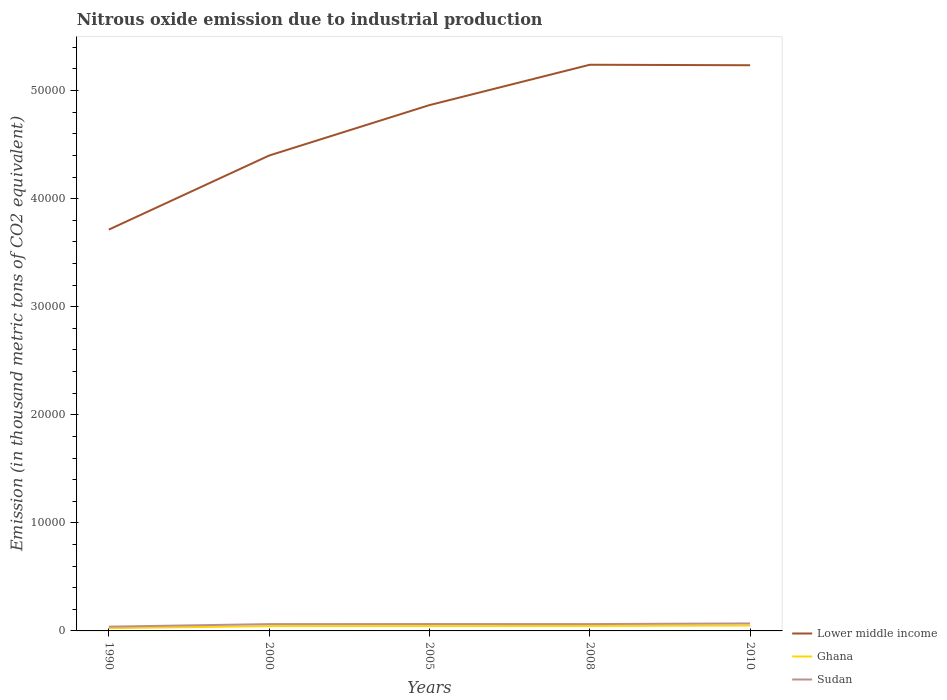Does the line corresponding to Ghana intersect with the line corresponding to Sudan?
Offer a terse response. No. Across all years, what is the maximum amount of nitrous oxide emitted in Sudan?
Offer a terse response. 395. What is the total amount of nitrous oxide emitted in Lower middle income in the graph?
Your answer should be very brief. -8354.9. What is the difference between the highest and the second highest amount of nitrous oxide emitted in Ghana?
Ensure brevity in your answer.  243.4. Is the amount of nitrous oxide emitted in Lower middle income strictly greater than the amount of nitrous oxide emitted in Sudan over the years?
Your answer should be very brief. No. How many years are there in the graph?
Make the answer very short. 5. What is the difference between two consecutive major ticks on the Y-axis?
Make the answer very short. 10000. Are the values on the major ticks of Y-axis written in scientific E-notation?
Your answer should be compact. No. Does the graph contain any zero values?
Keep it short and to the point. No. How are the legend labels stacked?
Offer a very short reply. Vertical. What is the title of the graph?
Provide a short and direct response. Nitrous oxide emission due to industrial production. Does "Myanmar" appear as one of the legend labels in the graph?
Make the answer very short. No. What is the label or title of the X-axis?
Keep it short and to the point. Years. What is the label or title of the Y-axis?
Offer a terse response. Emission (in thousand metric tons of CO2 equivalent). What is the Emission (in thousand metric tons of CO2 equivalent) in Lower middle income in 1990?
Ensure brevity in your answer.  3.71e+04. What is the Emission (in thousand metric tons of CO2 equivalent) in Ghana in 1990?
Provide a short and direct response. 256. What is the Emission (in thousand metric tons of CO2 equivalent) of Sudan in 1990?
Provide a short and direct response. 395. What is the Emission (in thousand metric tons of CO2 equivalent) in Lower middle income in 2000?
Keep it short and to the point. 4.40e+04. What is the Emission (in thousand metric tons of CO2 equivalent) in Ghana in 2000?
Give a very brief answer. 443.1. What is the Emission (in thousand metric tons of CO2 equivalent) of Sudan in 2000?
Your answer should be very brief. 630.1. What is the Emission (in thousand metric tons of CO2 equivalent) of Lower middle income in 2005?
Give a very brief answer. 4.87e+04. What is the Emission (in thousand metric tons of CO2 equivalent) of Ghana in 2005?
Your answer should be compact. 449.9. What is the Emission (in thousand metric tons of CO2 equivalent) of Sudan in 2005?
Your response must be concise. 637.4. What is the Emission (in thousand metric tons of CO2 equivalent) of Lower middle income in 2008?
Offer a terse response. 5.24e+04. What is the Emission (in thousand metric tons of CO2 equivalent) in Ghana in 2008?
Your response must be concise. 458.8. What is the Emission (in thousand metric tons of CO2 equivalent) of Sudan in 2008?
Offer a very short reply. 632.8. What is the Emission (in thousand metric tons of CO2 equivalent) in Lower middle income in 2010?
Ensure brevity in your answer.  5.23e+04. What is the Emission (in thousand metric tons of CO2 equivalent) of Ghana in 2010?
Ensure brevity in your answer.  499.4. What is the Emission (in thousand metric tons of CO2 equivalent) of Sudan in 2010?
Offer a terse response. 694.6. Across all years, what is the maximum Emission (in thousand metric tons of CO2 equivalent) in Lower middle income?
Ensure brevity in your answer.  5.24e+04. Across all years, what is the maximum Emission (in thousand metric tons of CO2 equivalent) of Ghana?
Make the answer very short. 499.4. Across all years, what is the maximum Emission (in thousand metric tons of CO2 equivalent) in Sudan?
Make the answer very short. 694.6. Across all years, what is the minimum Emission (in thousand metric tons of CO2 equivalent) of Lower middle income?
Your answer should be compact. 3.71e+04. Across all years, what is the minimum Emission (in thousand metric tons of CO2 equivalent) of Ghana?
Your response must be concise. 256. Across all years, what is the minimum Emission (in thousand metric tons of CO2 equivalent) of Sudan?
Your answer should be very brief. 395. What is the total Emission (in thousand metric tons of CO2 equivalent) in Lower middle income in the graph?
Offer a very short reply. 2.35e+05. What is the total Emission (in thousand metric tons of CO2 equivalent) in Ghana in the graph?
Offer a very short reply. 2107.2. What is the total Emission (in thousand metric tons of CO2 equivalent) in Sudan in the graph?
Your answer should be very brief. 2989.9. What is the difference between the Emission (in thousand metric tons of CO2 equivalent) in Lower middle income in 1990 and that in 2000?
Provide a succinct answer. -6854.5. What is the difference between the Emission (in thousand metric tons of CO2 equivalent) of Ghana in 1990 and that in 2000?
Offer a terse response. -187.1. What is the difference between the Emission (in thousand metric tons of CO2 equivalent) of Sudan in 1990 and that in 2000?
Your response must be concise. -235.1. What is the difference between the Emission (in thousand metric tons of CO2 equivalent) in Lower middle income in 1990 and that in 2005?
Your response must be concise. -1.15e+04. What is the difference between the Emission (in thousand metric tons of CO2 equivalent) of Ghana in 1990 and that in 2005?
Keep it short and to the point. -193.9. What is the difference between the Emission (in thousand metric tons of CO2 equivalent) of Sudan in 1990 and that in 2005?
Your response must be concise. -242.4. What is the difference between the Emission (in thousand metric tons of CO2 equivalent) of Lower middle income in 1990 and that in 2008?
Your answer should be compact. -1.53e+04. What is the difference between the Emission (in thousand metric tons of CO2 equivalent) in Ghana in 1990 and that in 2008?
Keep it short and to the point. -202.8. What is the difference between the Emission (in thousand metric tons of CO2 equivalent) of Sudan in 1990 and that in 2008?
Provide a short and direct response. -237.8. What is the difference between the Emission (in thousand metric tons of CO2 equivalent) in Lower middle income in 1990 and that in 2010?
Ensure brevity in your answer.  -1.52e+04. What is the difference between the Emission (in thousand metric tons of CO2 equivalent) of Ghana in 1990 and that in 2010?
Give a very brief answer. -243.4. What is the difference between the Emission (in thousand metric tons of CO2 equivalent) of Sudan in 1990 and that in 2010?
Ensure brevity in your answer.  -299.6. What is the difference between the Emission (in thousand metric tons of CO2 equivalent) in Lower middle income in 2000 and that in 2005?
Make the answer very short. -4665.5. What is the difference between the Emission (in thousand metric tons of CO2 equivalent) of Ghana in 2000 and that in 2005?
Ensure brevity in your answer.  -6.8. What is the difference between the Emission (in thousand metric tons of CO2 equivalent) of Sudan in 2000 and that in 2005?
Ensure brevity in your answer.  -7.3. What is the difference between the Emission (in thousand metric tons of CO2 equivalent) in Lower middle income in 2000 and that in 2008?
Your response must be concise. -8400.2. What is the difference between the Emission (in thousand metric tons of CO2 equivalent) of Ghana in 2000 and that in 2008?
Make the answer very short. -15.7. What is the difference between the Emission (in thousand metric tons of CO2 equivalent) of Sudan in 2000 and that in 2008?
Ensure brevity in your answer.  -2.7. What is the difference between the Emission (in thousand metric tons of CO2 equivalent) in Lower middle income in 2000 and that in 2010?
Offer a terse response. -8354.9. What is the difference between the Emission (in thousand metric tons of CO2 equivalent) in Ghana in 2000 and that in 2010?
Provide a short and direct response. -56.3. What is the difference between the Emission (in thousand metric tons of CO2 equivalent) in Sudan in 2000 and that in 2010?
Offer a terse response. -64.5. What is the difference between the Emission (in thousand metric tons of CO2 equivalent) in Lower middle income in 2005 and that in 2008?
Give a very brief answer. -3734.7. What is the difference between the Emission (in thousand metric tons of CO2 equivalent) in Ghana in 2005 and that in 2008?
Provide a short and direct response. -8.9. What is the difference between the Emission (in thousand metric tons of CO2 equivalent) of Sudan in 2005 and that in 2008?
Your response must be concise. 4.6. What is the difference between the Emission (in thousand metric tons of CO2 equivalent) of Lower middle income in 2005 and that in 2010?
Provide a short and direct response. -3689.4. What is the difference between the Emission (in thousand metric tons of CO2 equivalent) of Ghana in 2005 and that in 2010?
Offer a very short reply. -49.5. What is the difference between the Emission (in thousand metric tons of CO2 equivalent) in Sudan in 2005 and that in 2010?
Make the answer very short. -57.2. What is the difference between the Emission (in thousand metric tons of CO2 equivalent) in Lower middle income in 2008 and that in 2010?
Offer a very short reply. 45.3. What is the difference between the Emission (in thousand metric tons of CO2 equivalent) of Ghana in 2008 and that in 2010?
Keep it short and to the point. -40.6. What is the difference between the Emission (in thousand metric tons of CO2 equivalent) of Sudan in 2008 and that in 2010?
Give a very brief answer. -61.8. What is the difference between the Emission (in thousand metric tons of CO2 equivalent) of Lower middle income in 1990 and the Emission (in thousand metric tons of CO2 equivalent) of Ghana in 2000?
Your answer should be very brief. 3.67e+04. What is the difference between the Emission (in thousand metric tons of CO2 equivalent) in Lower middle income in 1990 and the Emission (in thousand metric tons of CO2 equivalent) in Sudan in 2000?
Offer a terse response. 3.65e+04. What is the difference between the Emission (in thousand metric tons of CO2 equivalent) in Ghana in 1990 and the Emission (in thousand metric tons of CO2 equivalent) in Sudan in 2000?
Your answer should be very brief. -374.1. What is the difference between the Emission (in thousand metric tons of CO2 equivalent) of Lower middle income in 1990 and the Emission (in thousand metric tons of CO2 equivalent) of Ghana in 2005?
Your answer should be very brief. 3.67e+04. What is the difference between the Emission (in thousand metric tons of CO2 equivalent) of Lower middle income in 1990 and the Emission (in thousand metric tons of CO2 equivalent) of Sudan in 2005?
Your answer should be very brief. 3.65e+04. What is the difference between the Emission (in thousand metric tons of CO2 equivalent) in Ghana in 1990 and the Emission (in thousand metric tons of CO2 equivalent) in Sudan in 2005?
Offer a terse response. -381.4. What is the difference between the Emission (in thousand metric tons of CO2 equivalent) of Lower middle income in 1990 and the Emission (in thousand metric tons of CO2 equivalent) of Ghana in 2008?
Your answer should be compact. 3.67e+04. What is the difference between the Emission (in thousand metric tons of CO2 equivalent) in Lower middle income in 1990 and the Emission (in thousand metric tons of CO2 equivalent) in Sudan in 2008?
Offer a very short reply. 3.65e+04. What is the difference between the Emission (in thousand metric tons of CO2 equivalent) of Ghana in 1990 and the Emission (in thousand metric tons of CO2 equivalent) of Sudan in 2008?
Your answer should be compact. -376.8. What is the difference between the Emission (in thousand metric tons of CO2 equivalent) of Lower middle income in 1990 and the Emission (in thousand metric tons of CO2 equivalent) of Ghana in 2010?
Provide a succinct answer. 3.66e+04. What is the difference between the Emission (in thousand metric tons of CO2 equivalent) of Lower middle income in 1990 and the Emission (in thousand metric tons of CO2 equivalent) of Sudan in 2010?
Offer a terse response. 3.64e+04. What is the difference between the Emission (in thousand metric tons of CO2 equivalent) of Ghana in 1990 and the Emission (in thousand metric tons of CO2 equivalent) of Sudan in 2010?
Your answer should be compact. -438.6. What is the difference between the Emission (in thousand metric tons of CO2 equivalent) in Lower middle income in 2000 and the Emission (in thousand metric tons of CO2 equivalent) in Ghana in 2005?
Your answer should be compact. 4.35e+04. What is the difference between the Emission (in thousand metric tons of CO2 equivalent) in Lower middle income in 2000 and the Emission (in thousand metric tons of CO2 equivalent) in Sudan in 2005?
Provide a succinct answer. 4.33e+04. What is the difference between the Emission (in thousand metric tons of CO2 equivalent) of Ghana in 2000 and the Emission (in thousand metric tons of CO2 equivalent) of Sudan in 2005?
Ensure brevity in your answer.  -194.3. What is the difference between the Emission (in thousand metric tons of CO2 equivalent) of Lower middle income in 2000 and the Emission (in thousand metric tons of CO2 equivalent) of Ghana in 2008?
Ensure brevity in your answer.  4.35e+04. What is the difference between the Emission (in thousand metric tons of CO2 equivalent) in Lower middle income in 2000 and the Emission (in thousand metric tons of CO2 equivalent) in Sudan in 2008?
Give a very brief answer. 4.34e+04. What is the difference between the Emission (in thousand metric tons of CO2 equivalent) of Ghana in 2000 and the Emission (in thousand metric tons of CO2 equivalent) of Sudan in 2008?
Your answer should be compact. -189.7. What is the difference between the Emission (in thousand metric tons of CO2 equivalent) in Lower middle income in 2000 and the Emission (in thousand metric tons of CO2 equivalent) in Ghana in 2010?
Ensure brevity in your answer.  4.35e+04. What is the difference between the Emission (in thousand metric tons of CO2 equivalent) in Lower middle income in 2000 and the Emission (in thousand metric tons of CO2 equivalent) in Sudan in 2010?
Your answer should be very brief. 4.33e+04. What is the difference between the Emission (in thousand metric tons of CO2 equivalent) in Ghana in 2000 and the Emission (in thousand metric tons of CO2 equivalent) in Sudan in 2010?
Offer a very short reply. -251.5. What is the difference between the Emission (in thousand metric tons of CO2 equivalent) of Lower middle income in 2005 and the Emission (in thousand metric tons of CO2 equivalent) of Ghana in 2008?
Your answer should be very brief. 4.82e+04. What is the difference between the Emission (in thousand metric tons of CO2 equivalent) of Lower middle income in 2005 and the Emission (in thousand metric tons of CO2 equivalent) of Sudan in 2008?
Make the answer very short. 4.80e+04. What is the difference between the Emission (in thousand metric tons of CO2 equivalent) in Ghana in 2005 and the Emission (in thousand metric tons of CO2 equivalent) in Sudan in 2008?
Ensure brevity in your answer.  -182.9. What is the difference between the Emission (in thousand metric tons of CO2 equivalent) in Lower middle income in 2005 and the Emission (in thousand metric tons of CO2 equivalent) in Ghana in 2010?
Offer a very short reply. 4.82e+04. What is the difference between the Emission (in thousand metric tons of CO2 equivalent) of Lower middle income in 2005 and the Emission (in thousand metric tons of CO2 equivalent) of Sudan in 2010?
Your answer should be compact. 4.80e+04. What is the difference between the Emission (in thousand metric tons of CO2 equivalent) in Ghana in 2005 and the Emission (in thousand metric tons of CO2 equivalent) in Sudan in 2010?
Your response must be concise. -244.7. What is the difference between the Emission (in thousand metric tons of CO2 equivalent) of Lower middle income in 2008 and the Emission (in thousand metric tons of CO2 equivalent) of Ghana in 2010?
Give a very brief answer. 5.19e+04. What is the difference between the Emission (in thousand metric tons of CO2 equivalent) of Lower middle income in 2008 and the Emission (in thousand metric tons of CO2 equivalent) of Sudan in 2010?
Provide a succinct answer. 5.17e+04. What is the difference between the Emission (in thousand metric tons of CO2 equivalent) in Ghana in 2008 and the Emission (in thousand metric tons of CO2 equivalent) in Sudan in 2010?
Provide a short and direct response. -235.8. What is the average Emission (in thousand metric tons of CO2 equivalent) of Lower middle income per year?
Make the answer very short. 4.69e+04. What is the average Emission (in thousand metric tons of CO2 equivalent) of Ghana per year?
Keep it short and to the point. 421.44. What is the average Emission (in thousand metric tons of CO2 equivalent) of Sudan per year?
Offer a terse response. 597.98. In the year 1990, what is the difference between the Emission (in thousand metric tons of CO2 equivalent) in Lower middle income and Emission (in thousand metric tons of CO2 equivalent) in Ghana?
Your answer should be very brief. 3.69e+04. In the year 1990, what is the difference between the Emission (in thousand metric tons of CO2 equivalent) in Lower middle income and Emission (in thousand metric tons of CO2 equivalent) in Sudan?
Your answer should be very brief. 3.67e+04. In the year 1990, what is the difference between the Emission (in thousand metric tons of CO2 equivalent) of Ghana and Emission (in thousand metric tons of CO2 equivalent) of Sudan?
Give a very brief answer. -139. In the year 2000, what is the difference between the Emission (in thousand metric tons of CO2 equivalent) of Lower middle income and Emission (in thousand metric tons of CO2 equivalent) of Ghana?
Your answer should be very brief. 4.35e+04. In the year 2000, what is the difference between the Emission (in thousand metric tons of CO2 equivalent) in Lower middle income and Emission (in thousand metric tons of CO2 equivalent) in Sudan?
Make the answer very short. 4.34e+04. In the year 2000, what is the difference between the Emission (in thousand metric tons of CO2 equivalent) in Ghana and Emission (in thousand metric tons of CO2 equivalent) in Sudan?
Your response must be concise. -187. In the year 2005, what is the difference between the Emission (in thousand metric tons of CO2 equivalent) of Lower middle income and Emission (in thousand metric tons of CO2 equivalent) of Ghana?
Ensure brevity in your answer.  4.82e+04. In the year 2005, what is the difference between the Emission (in thousand metric tons of CO2 equivalent) in Lower middle income and Emission (in thousand metric tons of CO2 equivalent) in Sudan?
Your response must be concise. 4.80e+04. In the year 2005, what is the difference between the Emission (in thousand metric tons of CO2 equivalent) of Ghana and Emission (in thousand metric tons of CO2 equivalent) of Sudan?
Keep it short and to the point. -187.5. In the year 2008, what is the difference between the Emission (in thousand metric tons of CO2 equivalent) of Lower middle income and Emission (in thousand metric tons of CO2 equivalent) of Ghana?
Your response must be concise. 5.19e+04. In the year 2008, what is the difference between the Emission (in thousand metric tons of CO2 equivalent) in Lower middle income and Emission (in thousand metric tons of CO2 equivalent) in Sudan?
Provide a succinct answer. 5.18e+04. In the year 2008, what is the difference between the Emission (in thousand metric tons of CO2 equivalent) in Ghana and Emission (in thousand metric tons of CO2 equivalent) in Sudan?
Give a very brief answer. -174. In the year 2010, what is the difference between the Emission (in thousand metric tons of CO2 equivalent) of Lower middle income and Emission (in thousand metric tons of CO2 equivalent) of Ghana?
Make the answer very short. 5.18e+04. In the year 2010, what is the difference between the Emission (in thousand metric tons of CO2 equivalent) of Lower middle income and Emission (in thousand metric tons of CO2 equivalent) of Sudan?
Offer a terse response. 5.16e+04. In the year 2010, what is the difference between the Emission (in thousand metric tons of CO2 equivalent) in Ghana and Emission (in thousand metric tons of CO2 equivalent) in Sudan?
Provide a succinct answer. -195.2. What is the ratio of the Emission (in thousand metric tons of CO2 equivalent) in Lower middle income in 1990 to that in 2000?
Keep it short and to the point. 0.84. What is the ratio of the Emission (in thousand metric tons of CO2 equivalent) of Ghana in 1990 to that in 2000?
Make the answer very short. 0.58. What is the ratio of the Emission (in thousand metric tons of CO2 equivalent) of Sudan in 1990 to that in 2000?
Provide a short and direct response. 0.63. What is the ratio of the Emission (in thousand metric tons of CO2 equivalent) in Lower middle income in 1990 to that in 2005?
Ensure brevity in your answer.  0.76. What is the ratio of the Emission (in thousand metric tons of CO2 equivalent) of Ghana in 1990 to that in 2005?
Provide a short and direct response. 0.57. What is the ratio of the Emission (in thousand metric tons of CO2 equivalent) of Sudan in 1990 to that in 2005?
Your answer should be compact. 0.62. What is the ratio of the Emission (in thousand metric tons of CO2 equivalent) of Lower middle income in 1990 to that in 2008?
Offer a very short reply. 0.71. What is the ratio of the Emission (in thousand metric tons of CO2 equivalent) in Ghana in 1990 to that in 2008?
Your response must be concise. 0.56. What is the ratio of the Emission (in thousand metric tons of CO2 equivalent) of Sudan in 1990 to that in 2008?
Your answer should be compact. 0.62. What is the ratio of the Emission (in thousand metric tons of CO2 equivalent) in Lower middle income in 1990 to that in 2010?
Make the answer very short. 0.71. What is the ratio of the Emission (in thousand metric tons of CO2 equivalent) in Ghana in 1990 to that in 2010?
Your answer should be very brief. 0.51. What is the ratio of the Emission (in thousand metric tons of CO2 equivalent) in Sudan in 1990 to that in 2010?
Make the answer very short. 0.57. What is the ratio of the Emission (in thousand metric tons of CO2 equivalent) in Lower middle income in 2000 to that in 2005?
Your response must be concise. 0.9. What is the ratio of the Emission (in thousand metric tons of CO2 equivalent) of Ghana in 2000 to that in 2005?
Give a very brief answer. 0.98. What is the ratio of the Emission (in thousand metric tons of CO2 equivalent) in Lower middle income in 2000 to that in 2008?
Provide a succinct answer. 0.84. What is the ratio of the Emission (in thousand metric tons of CO2 equivalent) of Ghana in 2000 to that in 2008?
Ensure brevity in your answer.  0.97. What is the ratio of the Emission (in thousand metric tons of CO2 equivalent) in Lower middle income in 2000 to that in 2010?
Your answer should be compact. 0.84. What is the ratio of the Emission (in thousand metric tons of CO2 equivalent) of Ghana in 2000 to that in 2010?
Give a very brief answer. 0.89. What is the ratio of the Emission (in thousand metric tons of CO2 equivalent) in Sudan in 2000 to that in 2010?
Your answer should be very brief. 0.91. What is the ratio of the Emission (in thousand metric tons of CO2 equivalent) in Lower middle income in 2005 to that in 2008?
Your answer should be compact. 0.93. What is the ratio of the Emission (in thousand metric tons of CO2 equivalent) in Ghana in 2005 to that in 2008?
Offer a terse response. 0.98. What is the ratio of the Emission (in thousand metric tons of CO2 equivalent) in Sudan in 2005 to that in 2008?
Ensure brevity in your answer.  1.01. What is the ratio of the Emission (in thousand metric tons of CO2 equivalent) of Lower middle income in 2005 to that in 2010?
Provide a short and direct response. 0.93. What is the ratio of the Emission (in thousand metric tons of CO2 equivalent) in Ghana in 2005 to that in 2010?
Your answer should be compact. 0.9. What is the ratio of the Emission (in thousand metric tons of CO2 equivalent) of Sudan in 2005 to that in 2010?
Your answer should be compact. 0.92. What is the ratio of the Emission (in thousand metric tons of CO2 equivalent) in Ghana in 2008 to that in 2010?
Offer a terse response. 0.92. What is the ratio of the Emission (in thousand metric tons of CO2 equivalent) of Sudan in 2008 to that in 2010?
Your answer should be very brief. 0.91. What is the difference between the highest and the second highest Emission (in thousand metric tons of CO2 equivalent) of Lower middle income?
Ensure brevity in your answer.  45.3. What is the difference between the highest and the second highest Emission (in thousand metric tons of CO2 equivalent) in Ghana?
Make the answer very short. 40.6. What is the difference between the highest and the second highest Emission (in thousand metric tons of CO2 equivalent) in Sudan?
Provide a short and direct response. 57.2. What is the difference between the highest and the lowest Emission (in thousand metric tons of CO2 equivalent) of Lower middle income?
Make the answer very short. 1.53e+04. What is the difference between the highest and the lowest Emission (in thousand metric tons of CO2 equivalent) in Ghana?
Make the answer very short. 243.4. What is the difference between the highest and the lowest Emission (in thousand metric tons of CO2 equivalent) in Sudan?
Your response must be concise. 299.6. 